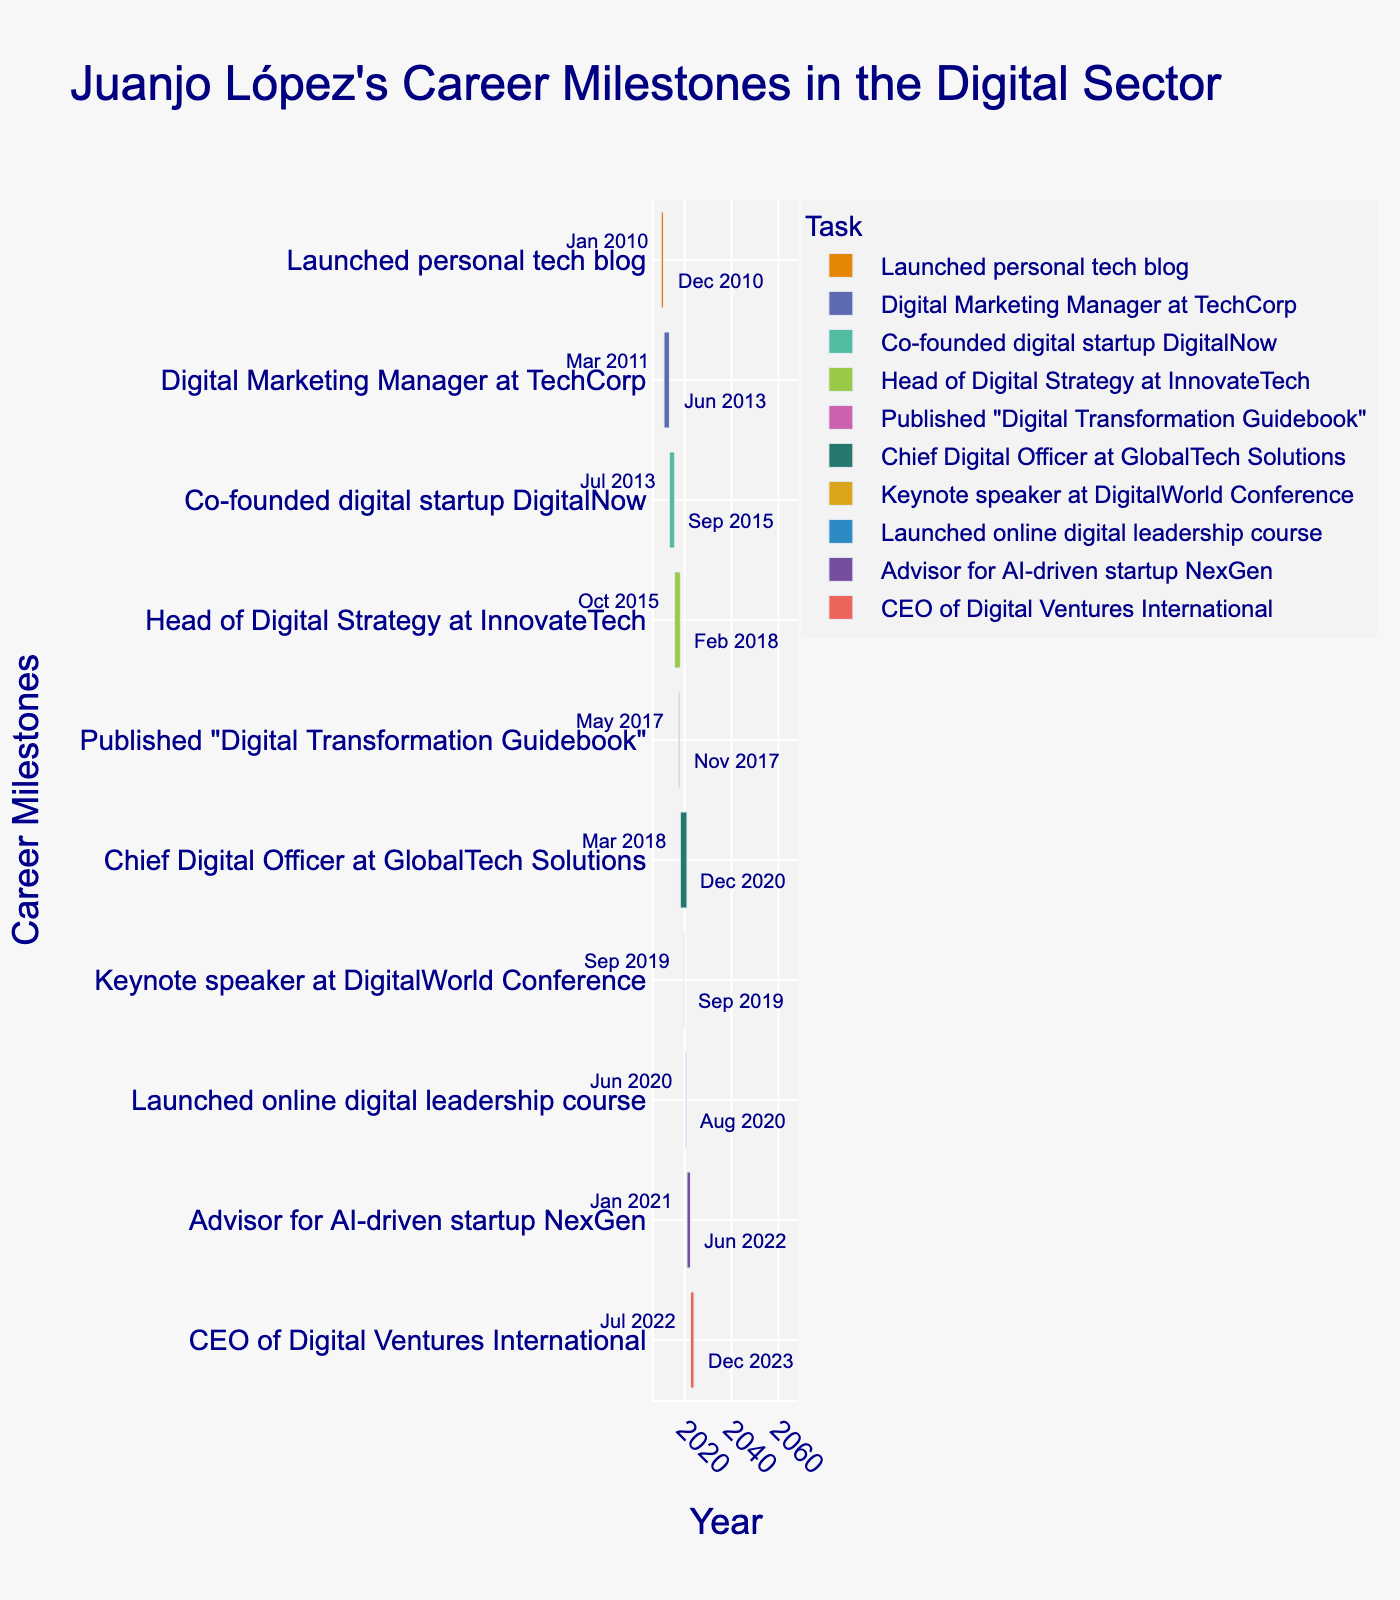What is the title of the Gantt chart? The title is found at the top of the chart and sets the context for the plot, indicating the subject matter it is representing.
Answer: Juanjo López's Career Milestones in the Digital Sector In which year did Juanjo López launch his personal tech blog? Look for the entry related to the personal tech blog and check its start date on the Gantt chart.
Answer: 2010 How long did Juanjo serve as Chief Digital Officer at GlobalTech Solutions? Identify the timeline for the role at GlobalTech Solutions and calculate the duration between the start and end dates. The duration is from March 2018 to December 2020.
Answer: 33 months Which career milestone overlaps with the time Juanjo was publishing the "Digital Transformation Guidebook"? Identify the timeline for the "Digital Transformation Guidebook" and see which other task intersects with this period from May 2017 to November 2017.
Answer: Head of Digital Strategy at InnovateTech For how many months did Juanjo López serve as an Advisor for NexGen? Determine the duration between the start (January 2021) and end (June 2022) dates on the chart.
Answer: 18 months Which milestone directly follows Juanjo's role as Digital Marketing Manager at TechCorp? Look for the milestone that starts immediately after the end date of the Digital Marketing Manager role, which ended in June 2013.
Answer: Co-founded digital startup DigitalNow How many career milestones are marked on Juanjo López's Gantt chart? Count the total number of distinct tasks listed on the y-axis of the Gantt chart.
Answer: 10 Which two milestones had the shortest duration, and what were their respective time spans? Find the tasks with the smallest duration by comparing the start and end dates. The shortest durations are "Keynote speaker at DigitalWorld Conference" and "Published 'Digital Transformation Guidebook'." The conference lasted only 3 days, and the book publishing project spanned 7 months.
Answer: DigitalWorld Conference: 3 days, Digital Transformation Guidebook: 7 months 